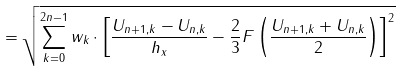Convert formula to latex. <formula><loc_0><loc_0><loc_500><loc_500>= \sqrt { \sum _ { k = 0 } ^ { 2 n - 1 } w _ { k } \cdot \left [ \frac { U _ { n + 1 , k } - U _ { n , k } } { h _ { x } } - \frac { 2 } { 3 } F \left ( \frac { U _ { n + 1 , k } + U _ { n , k } } { 2 } \right ) \right ] ^ { 2 } }</formula> 